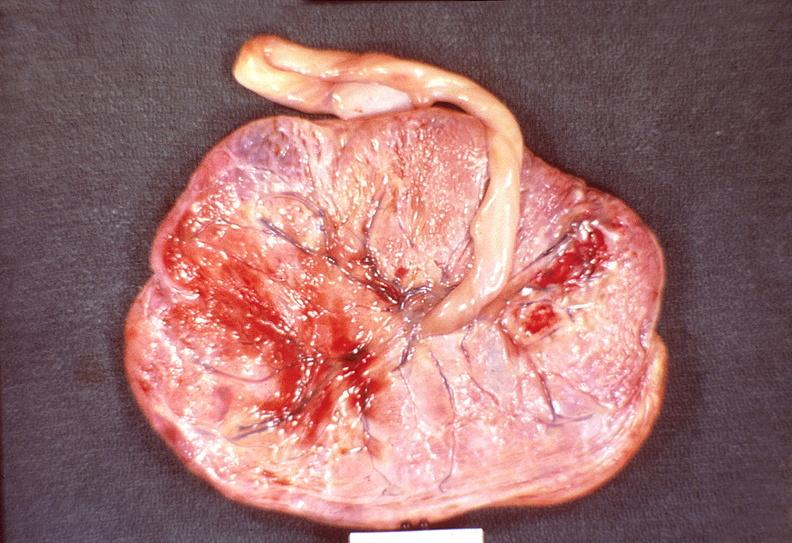does nodule show placenta, congestion and hemorrhage, hemolytic disease of newborn?
Answer the question using a single word or phrase. No 